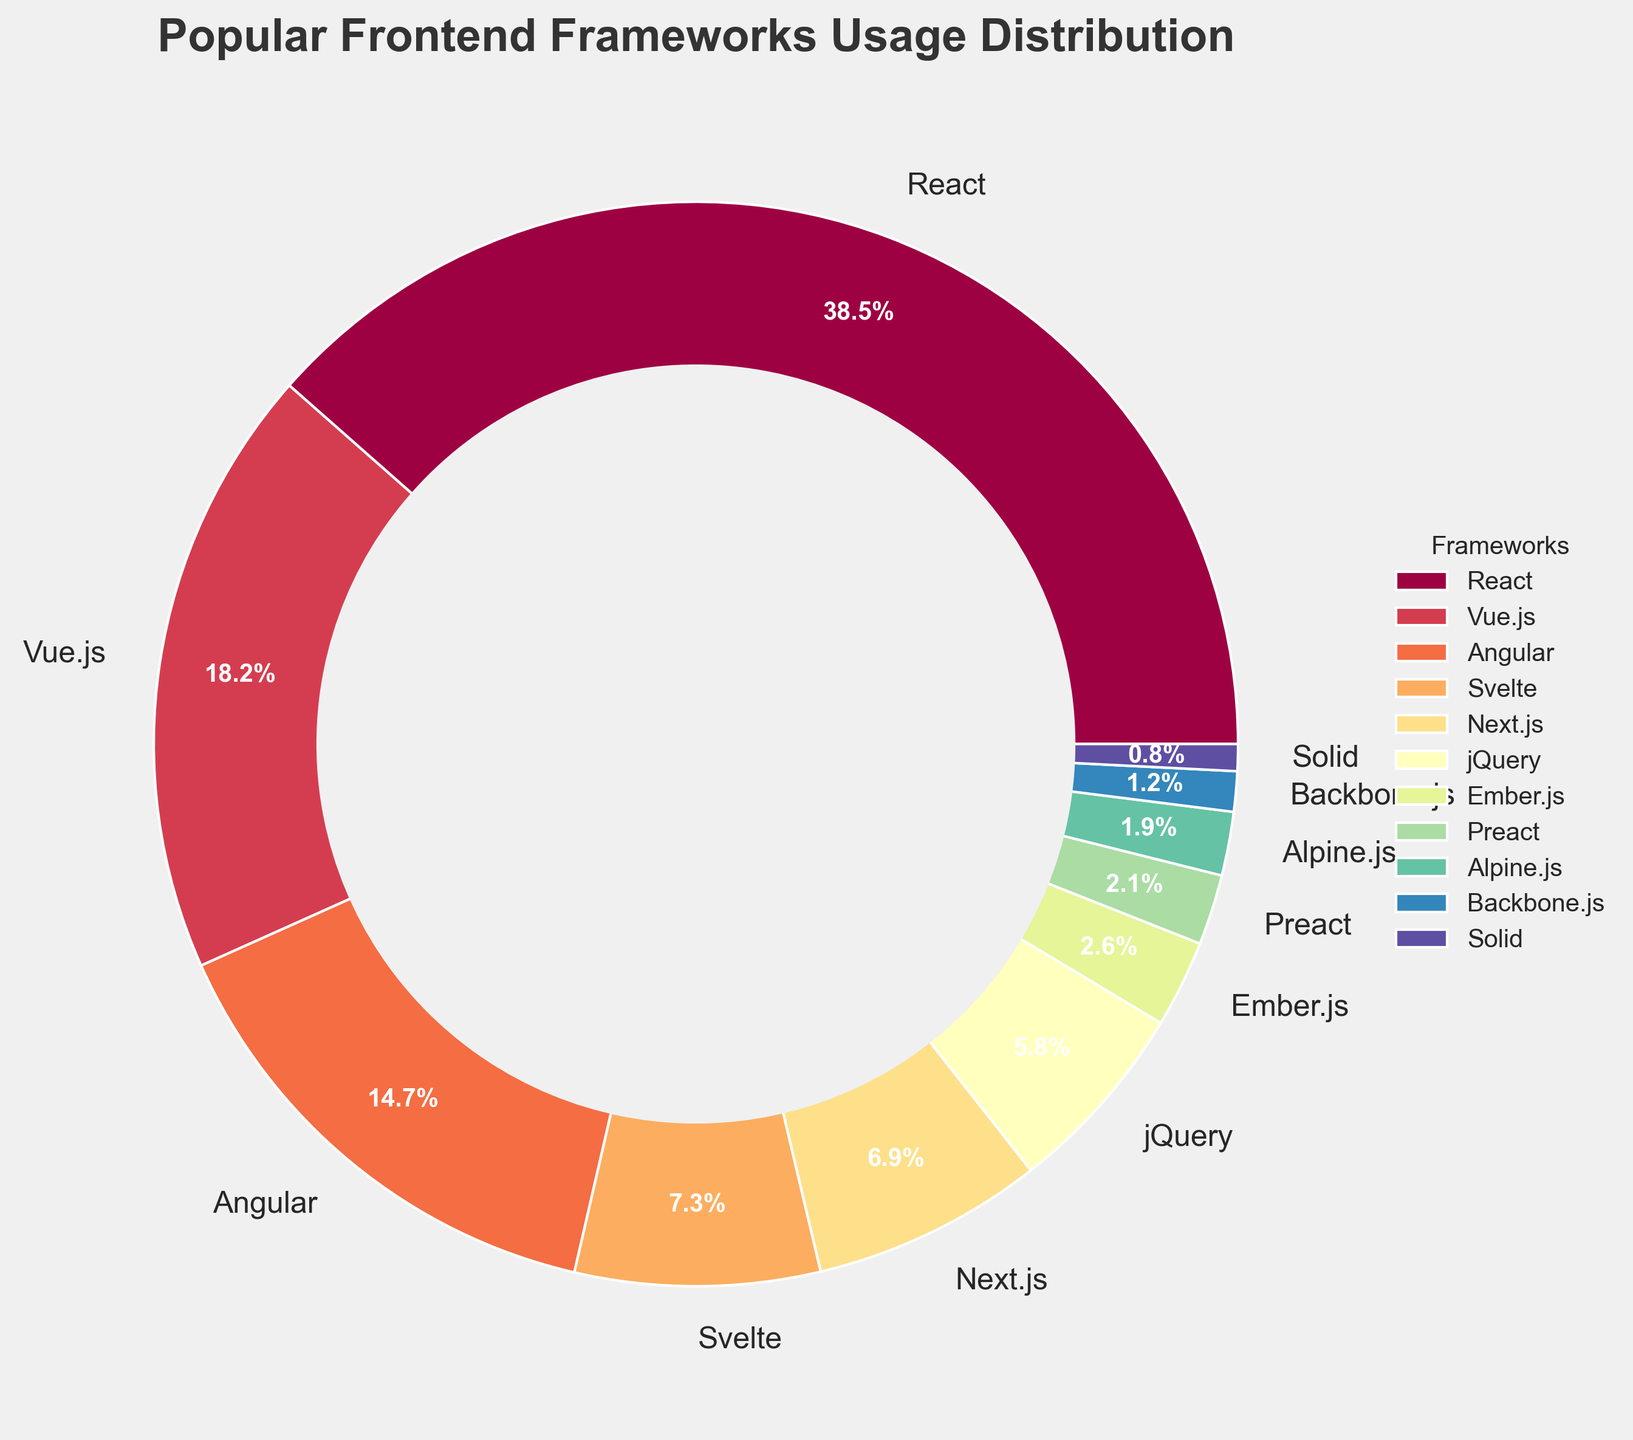Which frontend framework has the highest usage percentage? Look at the pie chart and identify the segment with the largest size. The framework corresponding to this segment has the highest usage percentage, which is React at 38.5%.
Answer: React What's the combined usage percentage of Vue.js and Angular? Find the percentages for Vue.js (18.2%) and Angular (14.7%) in the pie chart and sum them up. 18.2 + 14.7 = 32.9%.
Answer: 32.9% Which framework has a higher usage percentage, Svelte or Next.js? Compare the percentages of Svelte (7.3%) and Next.js (6.9%) in the pie chart to see which is higher. Svelte has a higher usage percentage.
Answer: Svelte How many frameworks have a usage percentage lower than 5%? Look at the pie chart and count the number of frameworks with segments representing less than 5%. These are jQuery, Ember.js, Preact, Alpine.js, Backbone.js, and Solid. There are six such frameworks.
Answer: 6 What's the percentage difference between the framework with the highest usage and the framework with the lowest usage? Identify the highest usage percentage (React at 38.5%) and the lowest usage percentage (Solid at 0.8%) in the pie chart. Subtract the lowest from the highest: 38.5 - 0.8 = 37.7%.
Answer: 37.7% If you add the usage percentages of Preact, Alpine.js, and Backbone.js, what is the result? Find the percentages for Preact (2.1%), Alpine.js (1.9%), and Backbone.js (1.2%). Add them together: 2.1 + 1.9 + 1.2 = 5.2%.
Answer: 5.2% Which framework usage is closest to 15%? Compare the percentages in the pie chart to 15%. Angular's usage (14.7%) is the closest to 15%.
Answer: Angular How does the usage of Vue.js compare to the combined usage of jQuery and Ember.js? Find the percentage for Vue.js (18.2%) and for jQuery (5.8%) and Ember.js (2.6%). Add the latter two: 5.8 + 2.6 = 8.4%. Vue.js (18.2%) is greater than the combined usage of jQuery and Ember.js (8.4%).
Answer: Vue.js > jQuery + Ember.js What's the total usage percentage of the frameworks with less than 2% usage? Identify frameworks with percentages less than 2% (Backbone.js at 1.2% and Solid at 0.8%). Add them: 1.2 + 0.8 = 2.0%.
Answer: 2.0% What is the average usage percentage of React, Angular, and jQuery? Find the percentages for React (38.5%), Angular (14.7%), and jQuery (5.8%). Calculate the average: (38.5 + 14.7 + 5.8) / 3 = 19.67%.
Answer: 19.67% 